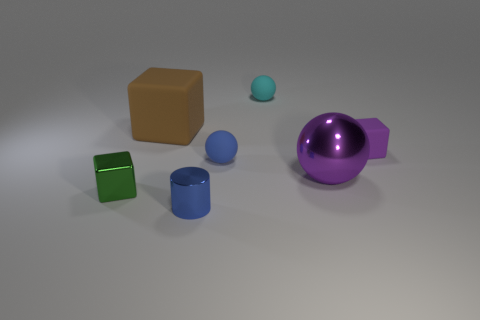How many other things are the same color as the metallic block?
Make the answer very short. 0. There is a tiny object that is the same color as the cylinder; what material is it?
Provide a succinct answer. Rubber. How many big objects are metal objects or brown metal objects?
Provide a succinct answer. 1. What color is the large sphere?
Your answer should be very brief. Purple. There is a small thing that is in front of the tiny metallic cube; are there any big balls that are behind it?
Your answer should be very brief. Yes. Is the number of cyan matte balls that are in front of the green metal thing less than the number of purple shiny objects?
Your answer should be very brief. Yes. Is the brown block that is behind the tiny blue matte sphere made of the same material as the small cyan thing?
Provide a succinct answer. Yes. The large cube that is the same material as the small purple object is what color?
Ensure brevity in your answer.  Brown. Is the number of shiny cylinders that are behind the tiny cyan rubber object less than the number of big purple metallic things that are behind the big purple object?
Your answer should be very brief. No. Does the matte thing to the right of the small cyan matte thing have the same color as the block that is in front of the tiny purple object?
Keep it short and to the point. No. 